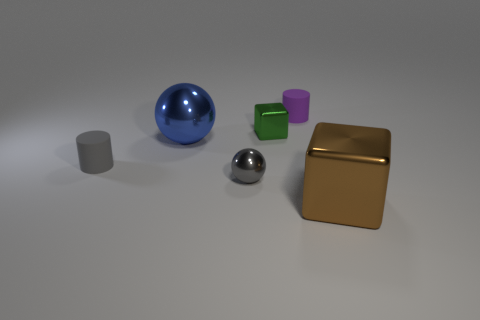What is the size of the thing on the right side of the rubber cylinder that is behind the large metallic object that is behind the small gray rubber cylinder?
Give a very brief answer. Large. What number of small green objects are the same material as the large blue ball?
Your answer should be very brief. 1. Are there fewer gray rubber cylinders than shiny balls?
Provide a succinct answer. Yes. What size is the blue object that is the same shape as the small gray metal object?
Your answer should be compact. Large. Do the large object that is in front of the big metal sphere and the tiny gray cylinder have the same material?
Give a very brief answer. No. Does the green metal object have the same shape as the large blue shiny thing?
Your response must be concise. No. What number of things are either tiny gray objects that are in front of the gray rubber object or gray objects?
Keep it short and to the point. 2. There is a blue thing that is made of the same material as the brown thing; what size is it?
Keep it short and to the point. Large. What number of tiny metallic spheres are the same color as the big metal sphere?
Keep it short and to the point. 0. What number of large objects are gray matte objects or blue things?
Offer a terse response. 1. 